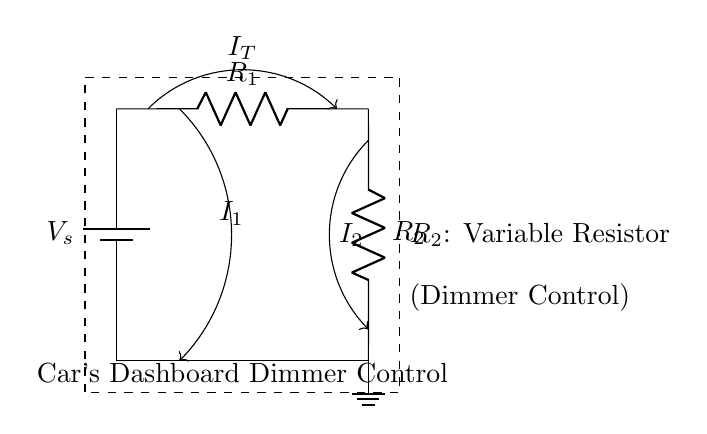What is the source voltage in the circuit? The source voltage, labeled as V_s, is indicated in the circuit diagram but is not specified. In practical applications, it could be a nominal voltage like 12V in a car's power system.
Answer: V_s What is the role of R_2 in this circuit? R_2 is labeled as a variable resistor, which means it can be adjusted to change the resistance. This functionality is typically used in dimmer controls to adjust the brightness of the dashboard lights.
Answer: Variable resistor What is the total current entering the circuit? The total current, represented by I_T, flows from the battery and splits into I_1 and I_2. The circuit diagram does not provide a numerical value, but it visually represents the total current entering the two parallel branches.
Answer: I_T How does the current split in a current divider? In a current divider, the total current is divided between the resistors based on their resistance values. Higher resistance results in lower current flow through that branch, while lower resistance allows more current. The relationship is I_1 = I_T * (R_total / R_1) and I_2 = I_T * (R_total / R_2).
Answer: According to resistance values What does the dashed box around the circuit represent? The dashed box is often used to indicate the boundaries of the circuit or to highlight a specific section within a larger circuit. In this case, it encloses the entire car's dashboard dimmer control circuit.
Answer: Circuit section What happens to the current if R_2 is increased? If R_2 is increased, the resistance in that branch increases, leading to a decrease in I_2 based on the current divider principle. This increase in resistance forces more current to flow through R_1, thus decreasing I_2 and increasing I_1, while keeping total current I_T constant.
Answer: I_2 decreases 